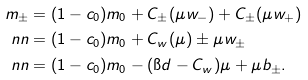Convert formula to latex. <formula><loc_0><loc_0><loc_500><loc_500>m _ { \pm } & = ( 1 - c _ { 0 } ) m _ { 0 } + C _ { \pm } ( \mu w _ { - } ) + C _ { \pm } ( \mu w _ { + } ) \\ \ n n & = ( 1 - c _ { 0 } ) m _ { 0 } + C _ { w } ( \mu ) \pm \mu w _ { \pm } \\ \ n n & = ( 1 - c _ { 0 } ) m _ { 0 } - ( \i d - C _ { w } ) \mu + \mu b _ { \pm } .</formula> 